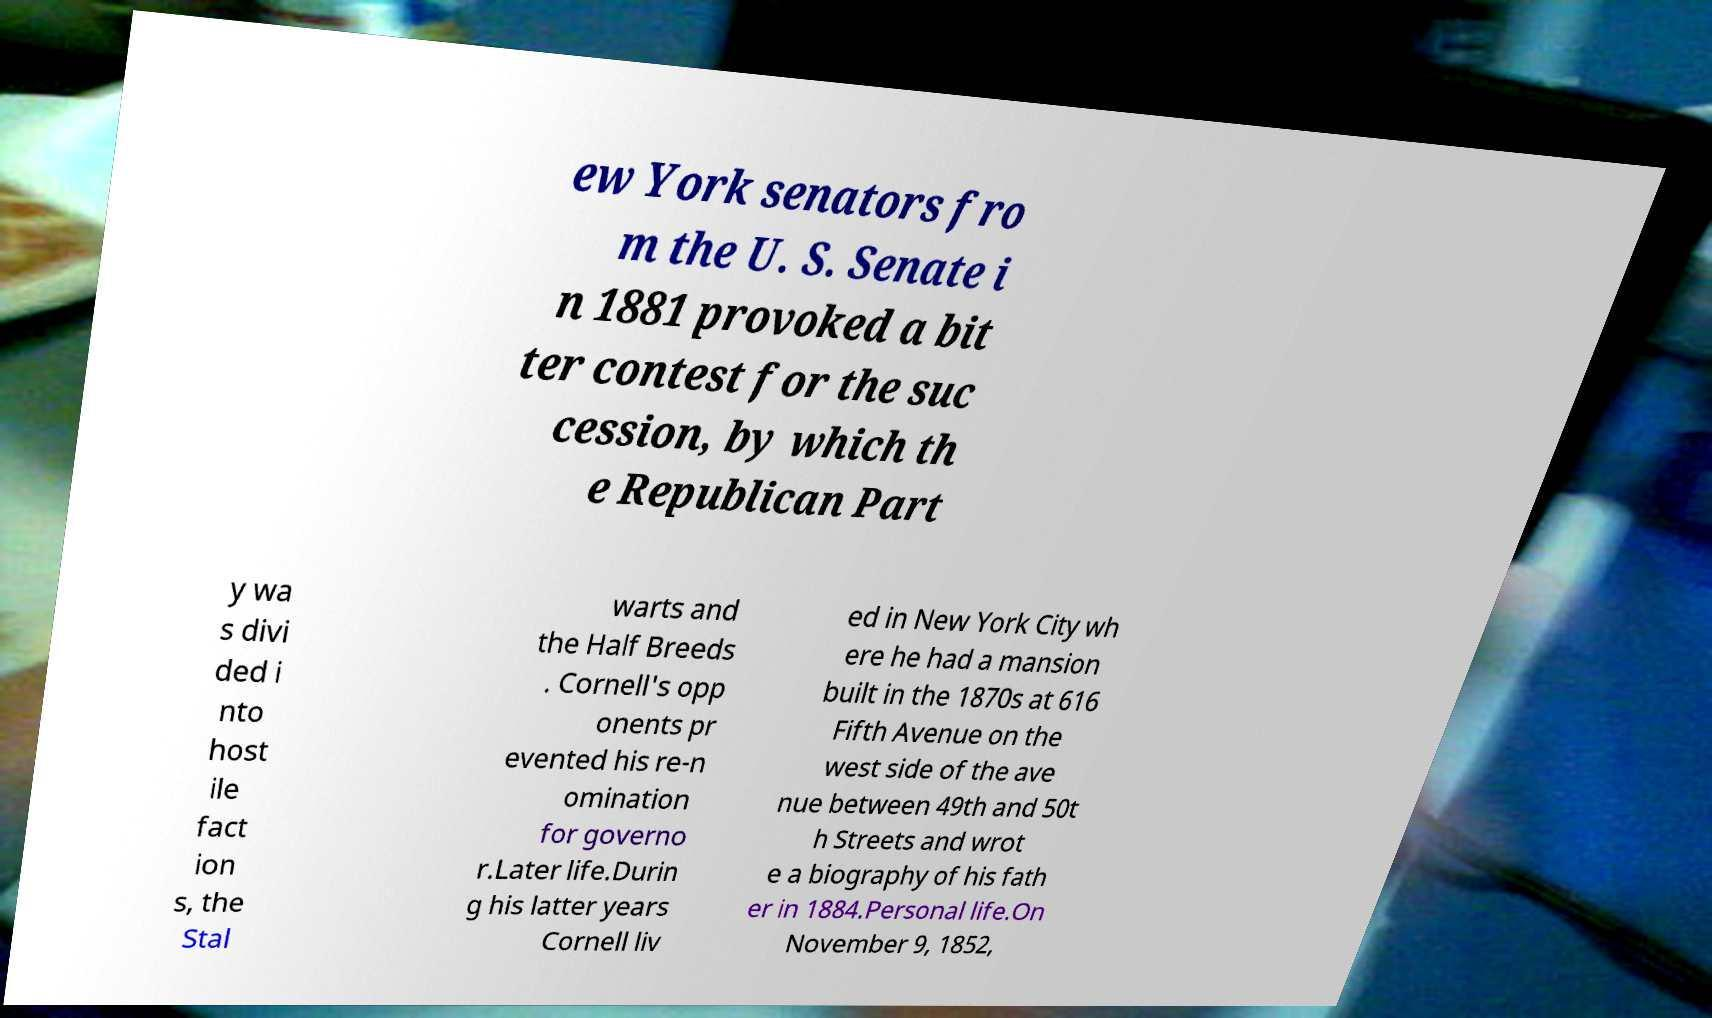There's text embedded in this image that I need extracted. Can you transcribe it verbatim? ew York senators fro m the U. S. Senate i n 1881 provoked a bit ter contest for the suc cession, by which th e Republican Part y wa s divi ded i nto host ile fact ion s, the Stal warts and the Half Breeds . Cornell's opp onents pr evented his re-n omination for governo r.Later life.Durin g his latter years Cornell liv ed in New York City wh ere he had a mansion built in the 1870s at 616 Fifth Avenue on the west side of the ave nue between 49th and 50t h Streets and wrot e a biography of his fath er in 1884.Personal life.On November 9, 1852, 